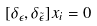<formula> <loc_0><loc_0><loc_500><loc_500>[ \delta _ { \epsilon } , \delta _ { \tilde { \epsilon } } ] x _ { i } = 0</formula> 